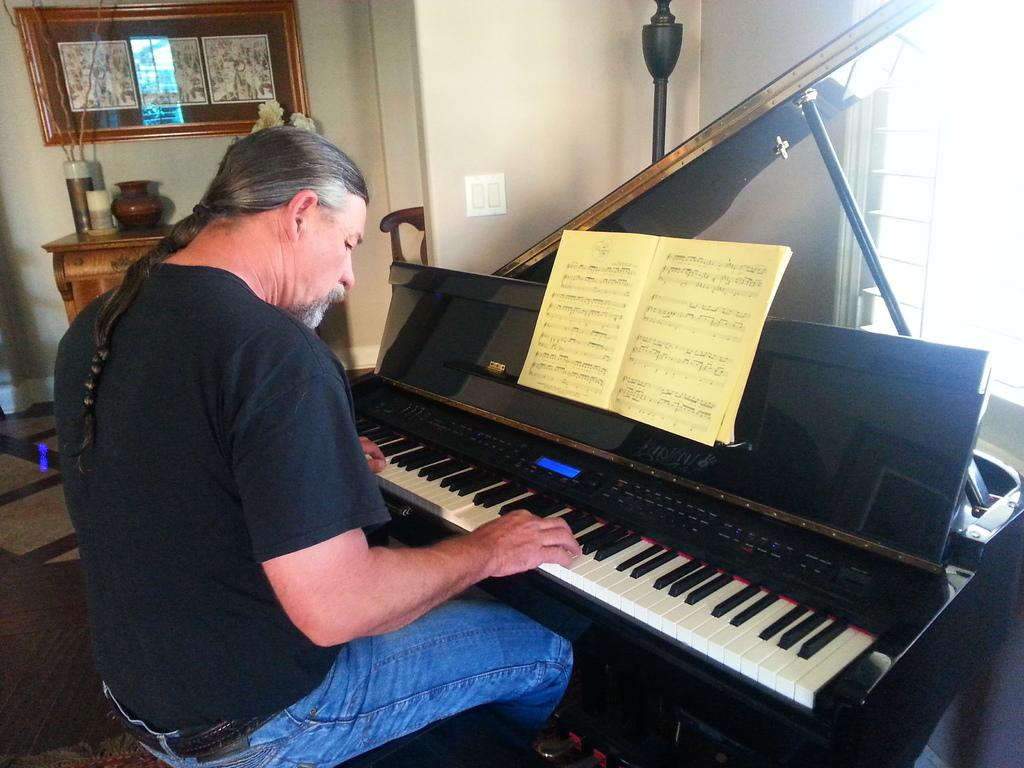What is the person in the image doing? The person is sitting and playing a piano keyboard. What can be seen above the piano? There is a book above the piano. What is visible in the background of the image? There is a wall, a window, a frame, and objects on a table in the background. What part of the room is visible? The floor is visible. What type of stocking is the person wearing while playing the piano? There is no information about the person's clothing, including stockings, in the image. 